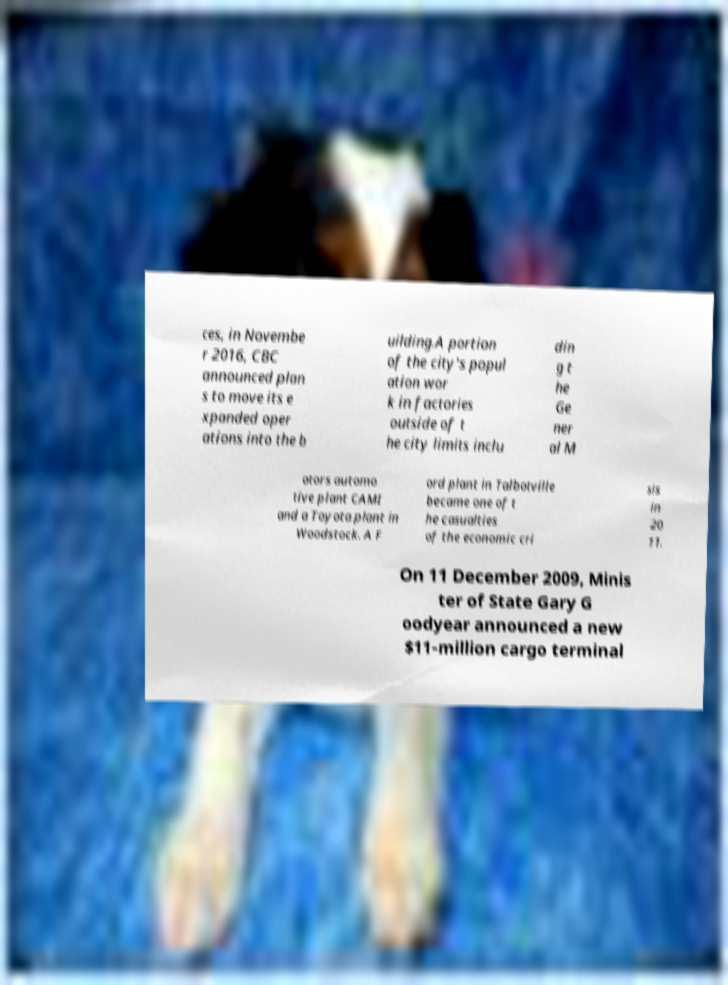There's text embedded in this image that I need extracted. Can you transcribe it verbatim? ces, in Novembe r 2016, CBC announced plan s to move its e xpanded oper ations into the b uilding.A portion of the city's popul ation wor k in factories outside of t he city limits inclu din g t he Ge ner al M otors automo tive plant CAMI and a Toyota plant in Woodstock. A F ord plant in Talbotville became one of t he casualties of the economic cri sis in 20 11. On 11 December 2009, Minis ter of State Gary G oodyear announced a new $11-million cargo terminal 